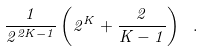<formula> <loc_0><loc_0><loc_500><loc_500>\frac { 1 } { 2 ^ { 2 K - 1 } } \left ( 2 ^ { K } + \frac { 2 } { K - 1 } \right ) \ .</formula> 